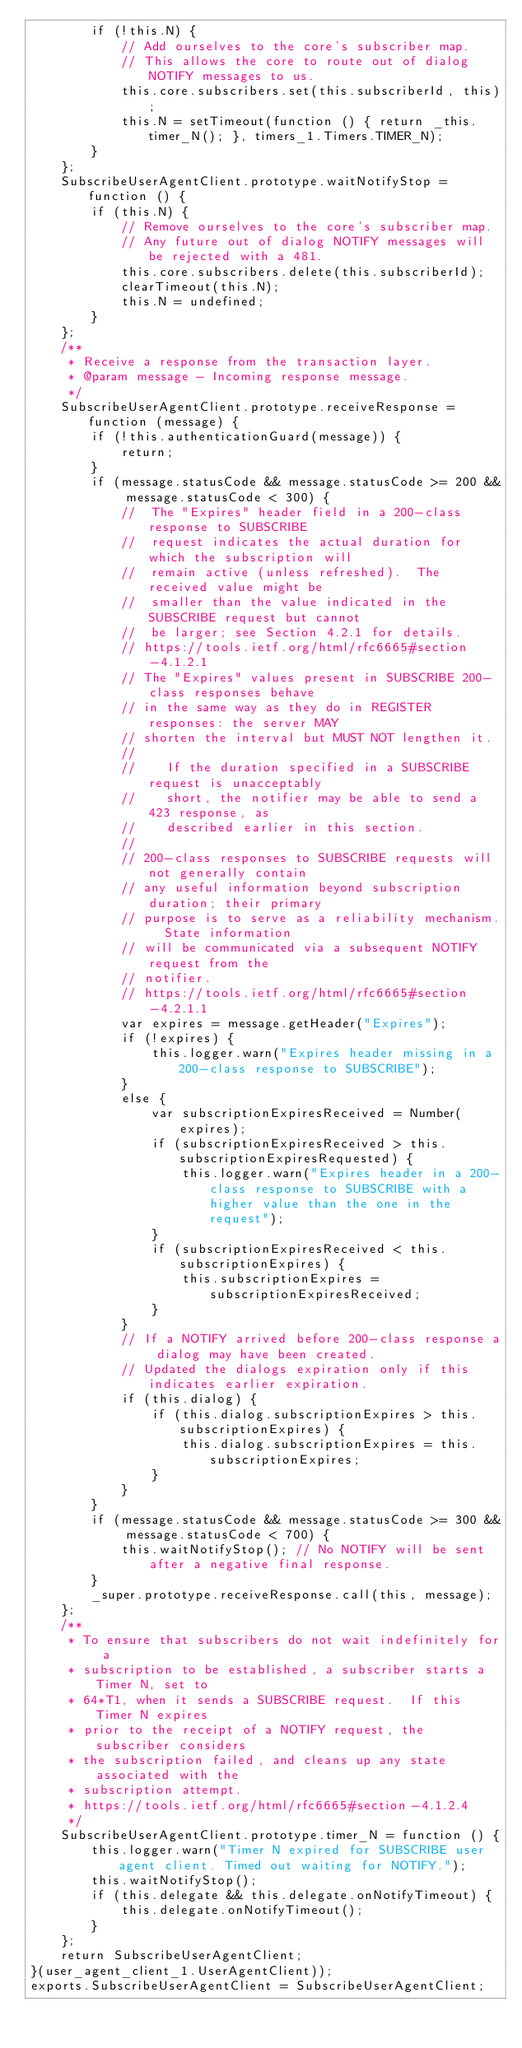<code> <loc_0><loc_0><loc_500><loc_500><_JavaScript_>        if (!this.N) {
            // Add ourselves to the core's subscriber map.
            // This allows the core to route out of dialog NOTIFY messages to us.
            this.core.subscribers.set(this.subscriberId, this);
            this.N = setTimeout(function () { return _this.timer_N(); }, timers_1.Timers.TIMER_N);
        }
    };
    SubscribeUserAgentClient.prototype.waitNotifyStop = function () {
        if (this.N) {
            // Remove ourselves to the core's subscriber map.
            // Any future out of dialog NOTIFY messages will be rejected with a 481.
            this.core.subscribers.delete(this.subscriberId);
            clearTimeout(this.N);
            this.N = undefined;
        }
    };
    /**
     * Receive a response from the transaction layer.
     * @param message - Incoming response message.
     */
    SubscribeUserAgentClient.prototype.receiveResponse = function (message) {
        if (!this.authenticationGuard(message)) {
            return;
        }
        if (message.statusCode && message.statusCode >= 200 && message.statusCode < 300) {
            //  The "Expires" header field in a 200-class response to SUBSCRIBE
            //  request indicates the actual duration for which the subscription will
            //  remain active (unless refreshed).  The received value might be
            //  smaller than the value indicated in the SUBSCRIBE request but cannot
            //  be larger; see Section 4.2.1 for details.
            // https://tools.ietf.org/html/rfc6665#section-4.1.2.1
            // The "Expires" values present in SUBSCRIBE 200-class responses behave
            // in the same way as they do in REGISTER responses: the server MAY
            // shorten the interval but MUST NOT lengthen it.
            //
            //    If the duration specified in a SUBSCRIBE request is unacceptably
            //    short, the notifier may be able to send a 423 response, as
            //    described earlier in this section.
            //
            // 200-class responses to SUBSCRIBE requests will not generally contain
            // any useful information beyond subscription duration; their primary
            // purpose is to serve as a reliability mechanism.  State information
            // will be communicated via a subsequent NOTIFY request from the
            // notifier.
            // https://tools.ietf.org/html/rfc6665#section-4.2.1.1
            var expires = message.getHeader("Expires");
            if (!expires) {
                this.logger.warn("Expires header missing in a 200-class response to SUBSCRIBE");
            }
            else {
                var subscriptionExpiresReceived = Number(expires);
                if (subscriptionExpiresReceived > this.subscriptionExpiresRequested) {
                    this.logger.warn("Expires header in a 200-class response to SUBSCRIBE with a higher value than the one in the request");
                }
                if (subscriptionExpiresReceived < this.subscriptionExpires) {
                    this.subscriptionExpires = subscriptionExpiresReceived;
                }
            }
            // If a NOTIFY arrived before 200-class response a dialog may have been created.
            // Updated the dialogs expiration only if this indicates earlier expiration.
            if (this.dialog) {
                if (this.dialog.subscriptionExpires > this.subscriptionExpires) {
                    this.dialog.subscriptionExpires = this.subscriptionExpires;
                }
            }
        }
        if (message.statusCode && message.statusCode >= 300 && message.statusCode < 700) {
            this.waitNotifyStop(); // No NOTIFY will be sent after a negative final response.
        }
        _super.prototype.receiveResponse.call(this, message);
    };
    /**
     * To ensure that subscribers do not wait indefinitely for a
     * subscription to be established, a subscriber starts a Timer N, set to
     * 64*T1, when it sends a SUBSCRIBE request.  If this Timer N expires
     * prior to the receipt of a NOTIFY request, the subscriber considers
     * the subscription failed, and cleans up any state associated with the
     * subscription attempt.
     * https://tools.ietf.org/html/rfc6665#section-4.1.2.4
     */
    SubscribeUserAgentClient.prototype.timer_N = function () {
        this.logger.warn("Timer N expired for SUBSCRIBE user agent client. Timed out waiting for NOTIFY.");
        this.waitNotifyStop();
        if (this.delegate && this.delegate.onNotifyTimeout) {
            this.delegate.onNotifyTimeout();
        }
    };
    return SubscribeUserAgentClient;
}(user_agent_client_1.UserAgentClient));
exports.SubscribeUserAgentClient = SubscribeUserAgentClient;
</code> 